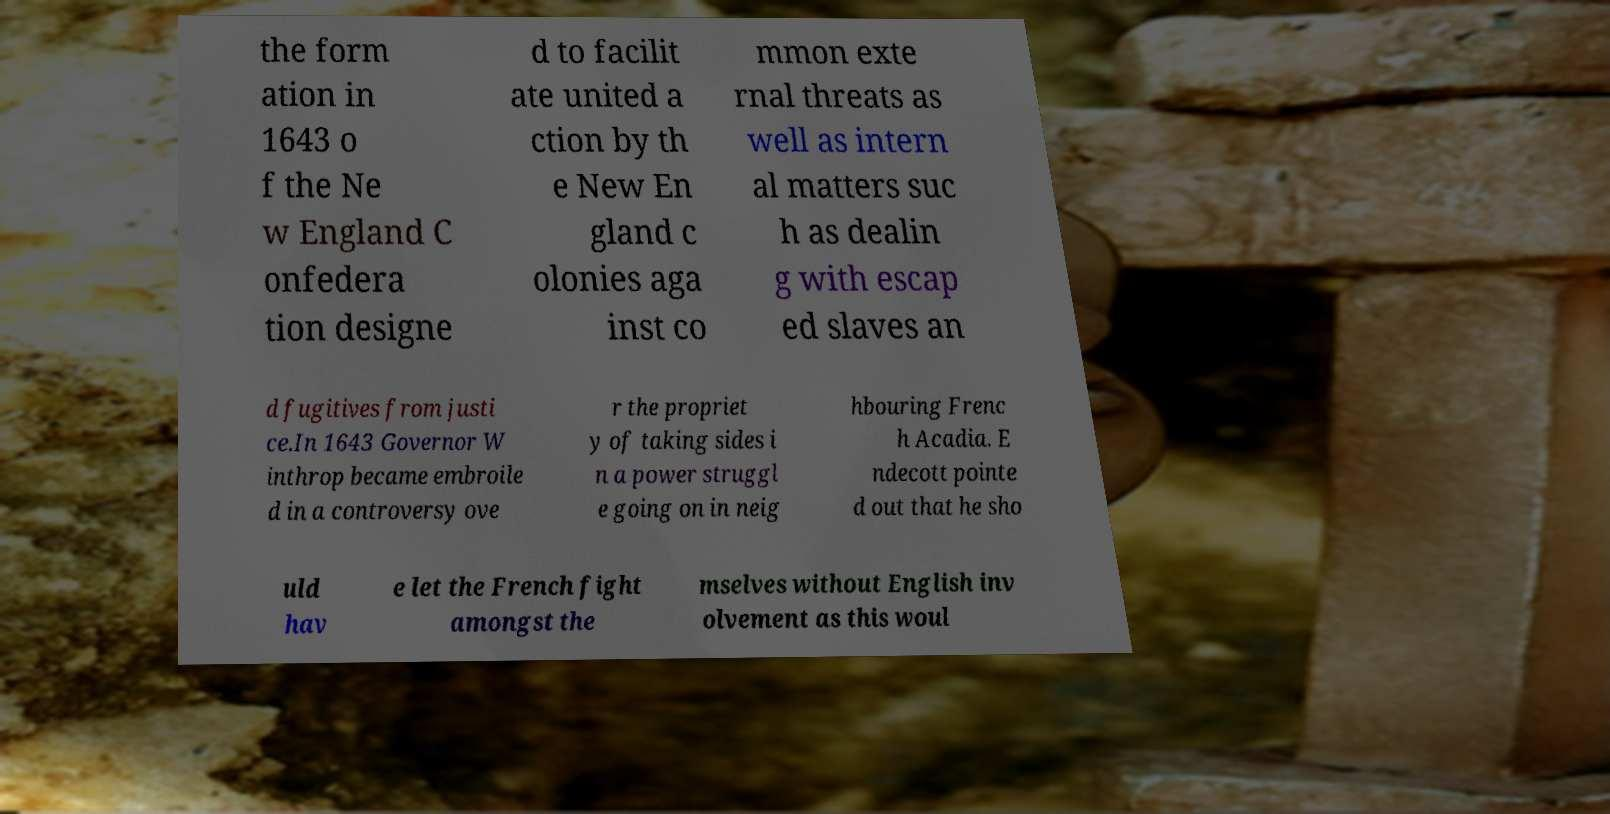I need the written content from this picture converted into text. Can you do that? the form ation in 1643 o f the Ne w England C onfedera tion designe d to facilit ate united a ction by th e New En gland c olonies aga inst co mmon exte rnal threats as well as intern al matters suc h as dealin g with escap ed slaves an d fugitives from justi ce.In 1643 Governor W inthrop became embroile d in a controversy ove r the propriet y of taking sides i n a power struggl e going on in neig hbouring Frenc h Acadia. E ndecott pointe d out that he sho uld hav e let the French fight amongst the mselves without English inv olvement as this woul 